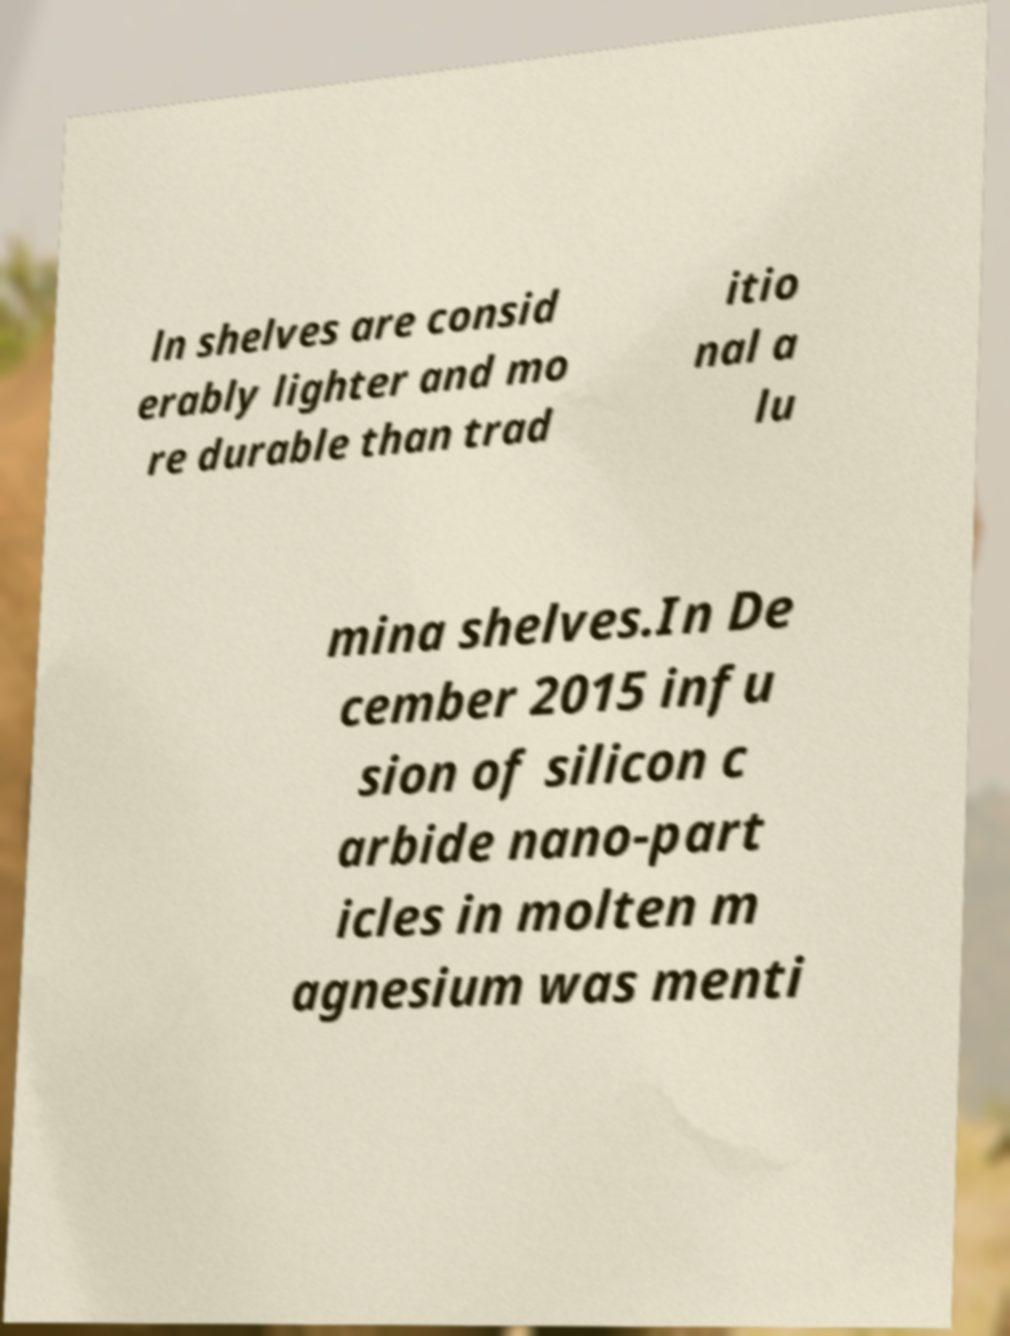Please identify and transcribe the text found in this image. ln shelves are consid erably lighter and mo re durable than trad itio nal a lu mina shelves.In De cember 2015 infu sion of silicon c arbide nano-part icles in molten m agnesium was menti 